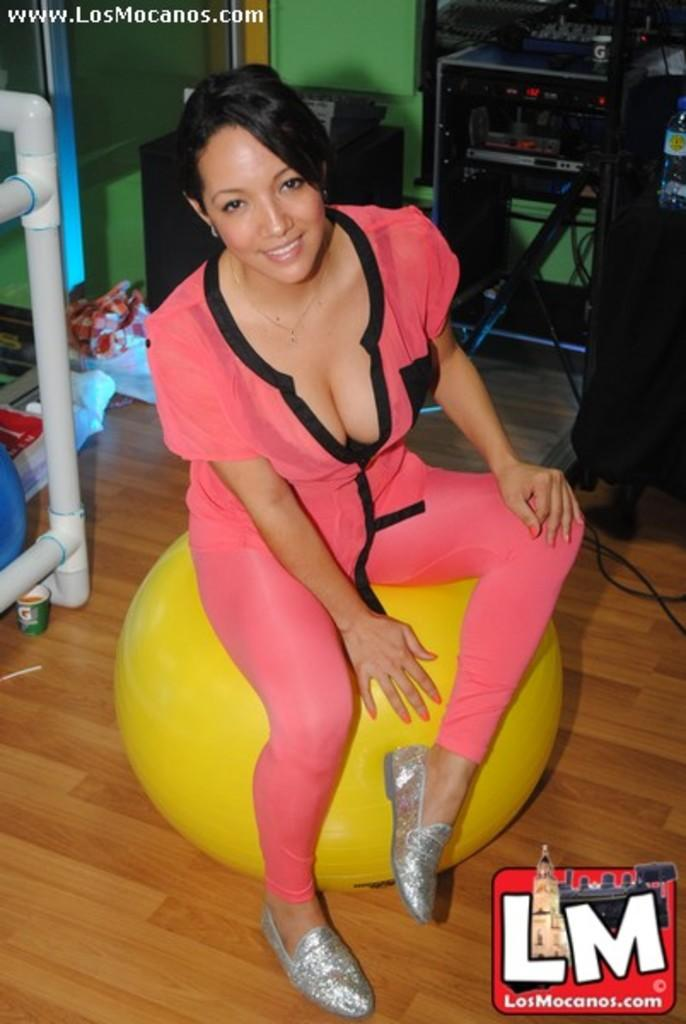What type of space is depicted in the image? The image shows the inner view of a room. What can be seen inside the room? There are two machines and a woman sitting on a fitness ball. What color is the wall in the room? The wall is green. What is on the floor in the room? There are different objects on the floor. What type of drink is the woman holding in the image? There is no drink visible in the image; the woman is sitting on a fitness ball. 